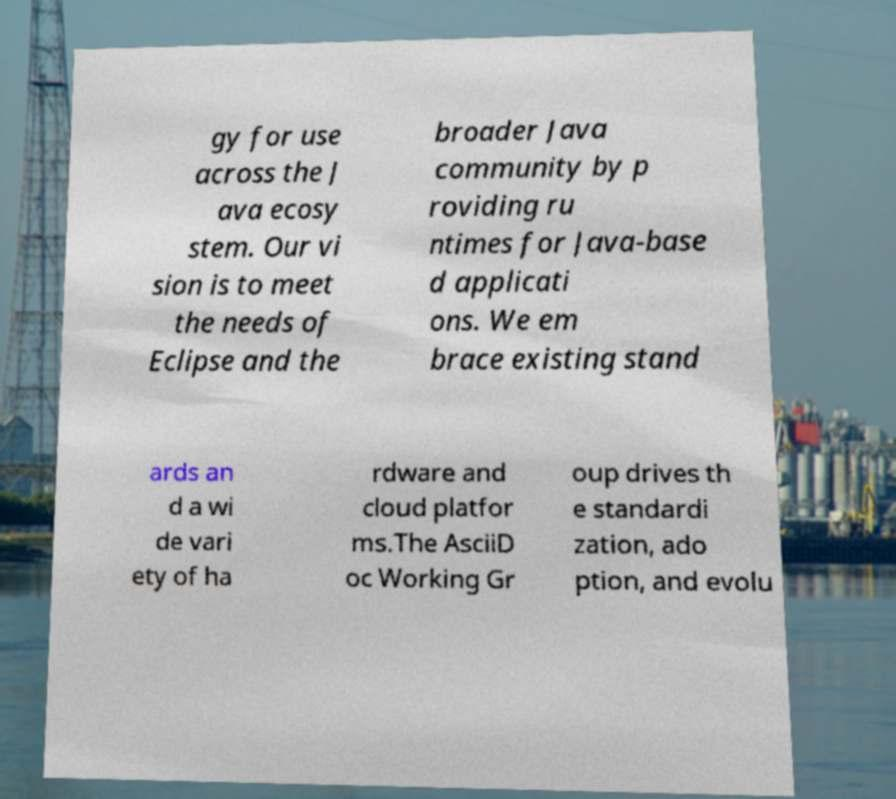There's text embedded in this image that I need extracted. Can you transcribe it verbatim? gy for use across the J ava ecosy stem. Our vi sion is to meet the needs of Eclipse and the broader Java community by p roviding ru ntimes for Java-base d applicati ons. We em brace existing stand ards an d a wi de vari ety of ha rdware and cloud platfor ms.The AsciiD oc Working Gr oup drives th e standardi zation, ado ption, and evolu 